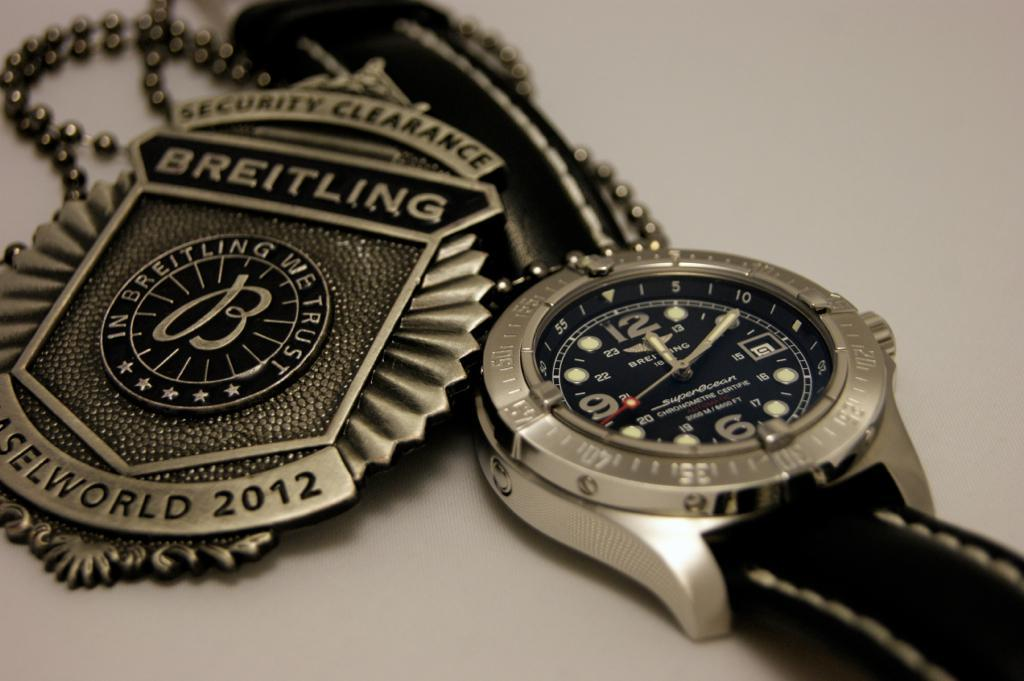<image>
Describe the image concisely. A Breitling watch and metal sit side by side. 